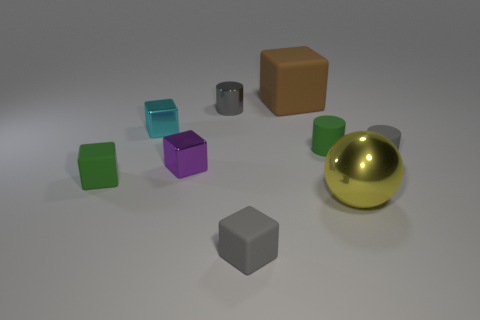Subtract all green blocks. How many blocks are left? 4 Subtract all big brown rubber blocks. How many blocks are left? 4 Subtract all purple cubes. Subtract all purple balls. How many cubes are left? 4 Subtract all blocks. How many objects are left? 4 Subtract 1 cyan cubes. How many objects are left? 8 Subtract all small yellow metallic balls. Subtract all cyan blocks. How many objects are left? 8 Add 2 large spheres. How many large spheres are left? 3 Add 3 large gray metal blocks. How many large gray metal blocks exist? 3 